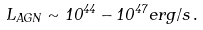Convert formula to latex. <formula><loc_0><loc_0><loc_500><loc_500>L _ { A G N } \sim 1 0 ^ { 4 4 } - 1 0 ^ { 4 7 } e r g / s \, .</formula> 